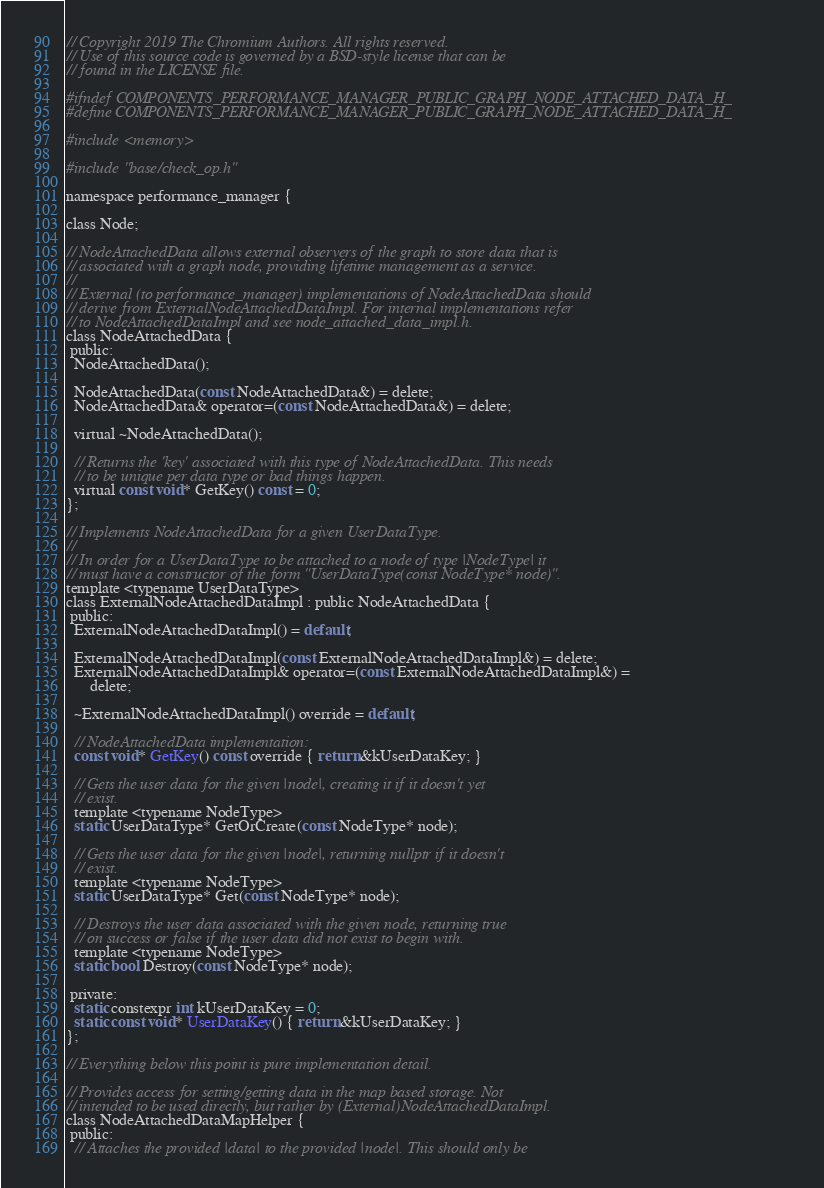<code> <loc_0><loc_0><loc_500><loc_500><_C_>// Copyright 2019 The Chromium Authors. All rights reserved.
// Use of this source code is governed by a BSD-style license that can be
// found in the LICENSE file.

#ifndef COMPONENTS_PERFORMANCE_MANAGER_PUBLIC_GRAPH_NODE_ATTACHED_DATA_H_
#define COMPONENTS_PERFORMANCE_MANAGER_PUBLIC_GRAPH_NODE_ATTACHED_DATA_H_

#include <memory>

#include "base/check_op.h"

namespace performance_manager {

class Node;

// NodeAttachedData allows external observers of the graph to store data that is
// associated with a graph node, providing lifetime management as a service.
//
// External (to performance_manager) implementations of NodeAttachedData should
// derive from ExternalNodeAttachedDataImpl. For internal implementations refer
// to NodeAttachedDataImpl and see node_attached_data_impl.h.
class NodeAttachedData {
 public:
  NodeAttachedData();

  NodeAttachedData(const NodeAttachedData&) = delete;
  NodeAttachedData& operator=(const NodeAttachedData&) = delete;

  virtual ~NodeAttachedData();

  // Returns the 'key' associated with this type of NodeAttachedData. This needs
  // to be unique per data type or bad things happen.
  virtual const void* GetKey() const = 0;
};

// Implements NodeAttachedData for a given UserDataType.
//
// In order for a UserDataType to be attached to a node of type |NodeType| it
// must have a constructor of the form "UserDataType(const NodeType* node)".
template <typename UserDataType>
class ExternalNodeAttachedDataImpl : public NodeAttachedData {
 public:
  ExternalNodeAttachedDataImpl() = default;

  ExternalNodeAttachedDataImpl(const ExternalNodeAttachedDataImpl&) = delete;
  ExternalNodeAttachedDataImpl& operator=(const ExternalNodeAttachedDataImpl&) =
      delete;

  ~ExternalNodeAttachedDataImpl() override = default;

  // NodeAttachedData implementation:
  const void* GetKey() const override { return &kUserDataKey; }

  // Gets the user data for the given |node|, creating it if it doesn't yet
  // exist.
  template <typename NodeType>
  static UserDataType* GetOrCreate(const NodeType* node);

  // Gets the user data for the given |node|, returning nullptr if it doesn't
  // exist.
  template <typename NodeType>
  static UserDataType* Get(const NodeType* node);

  // Destroys the user data associated with the given node, returning true
  // on success or false if the user data did not exist to begin with.
  template <typename NodeType>
  static bool Destroy(const NodeType* node);

 private:
  static constexpr int kUserDataKey = 0;
  static const void* UserDataKey() { return &kUserDataKey; }
};

// Everything below this point is pure implementation detail.

// Provides access for setting/getting data in the map based storage. Not
// intended to be used directly, but rather by (External)NodeAttachedDataImpl.
class NodeAttachedDataMapHelper {
 public:
  // Attaches the provided |data| to the provided |node|. This should only be</code> 